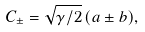<formula> <loc_0><loc_0><loc_500><loc_500>C _ { \pm } = \sqrt { \gamma / 2 } \, ( a \pm b ) ,</formula> 